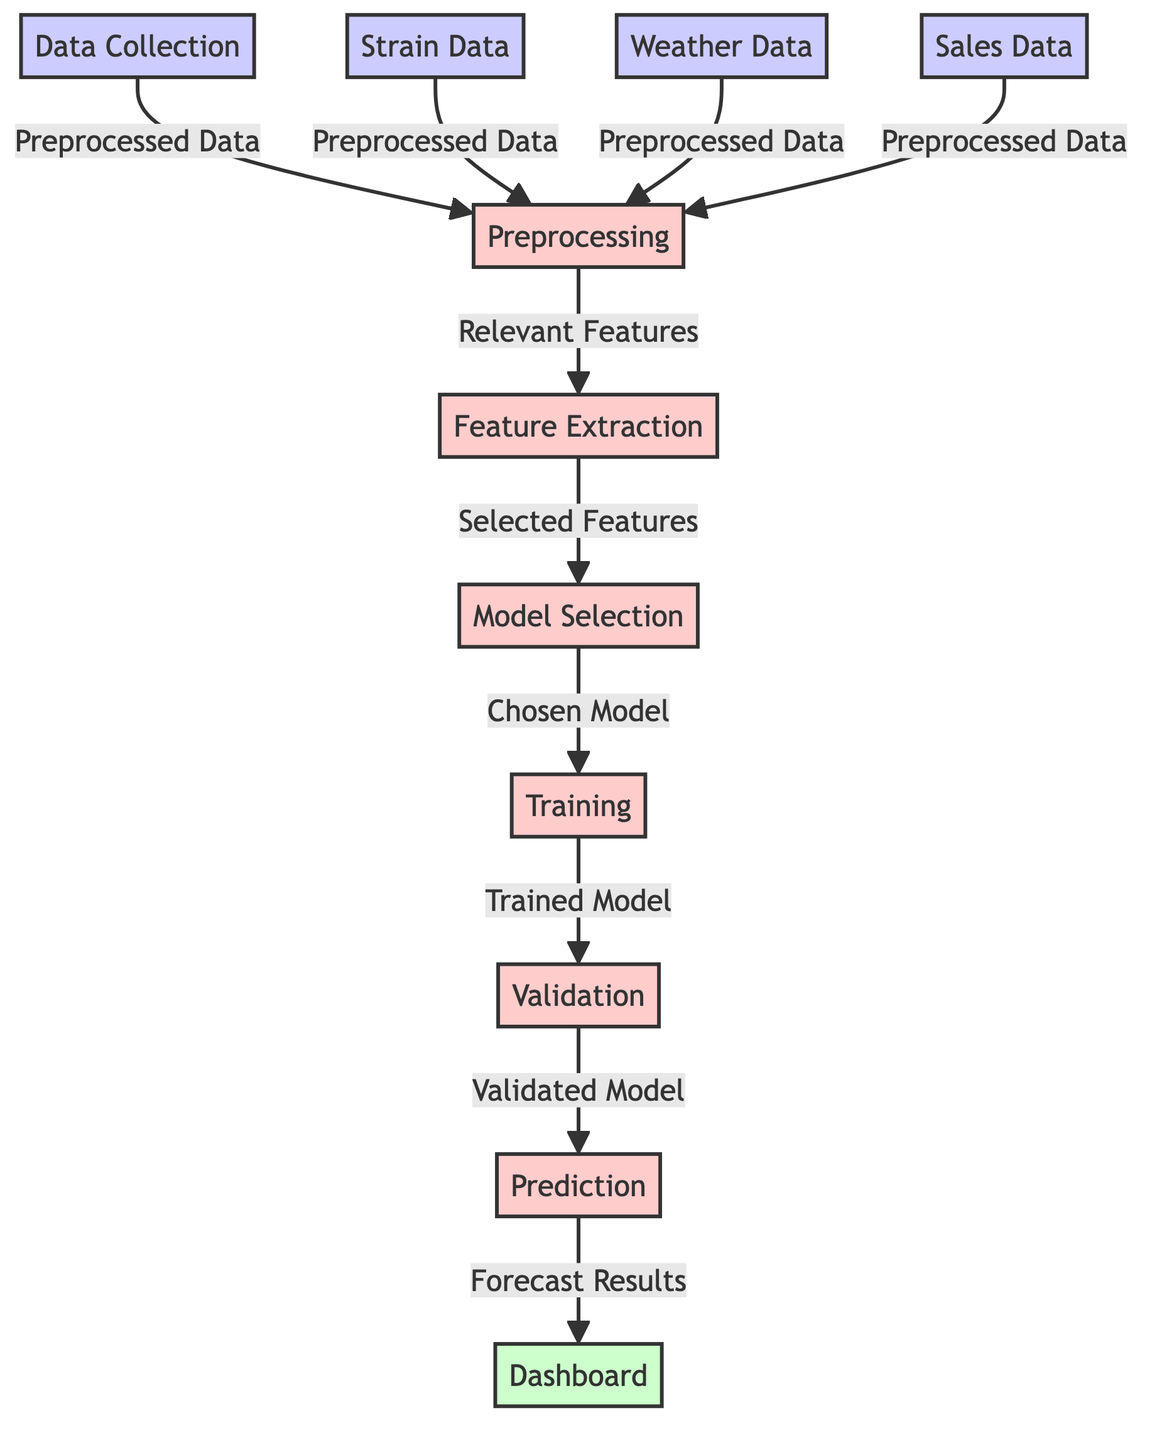What is the first step in the diagram? The first step in the diagram is "Data Collection," where initial data types are collected for further processing.
Answer: Data Collection How many types of data are collected before preprocessing? There are four types of data collected before preprocessing, which are strain data, weather data, sales data, and the general data collection.
Answer: Four Which process follows the "Feature Extraction"? The process that follows "Feature Extraction" is "Model Selection," where the selected features are used to choose an appropriate model for forecasting.
Answer: Model Selection What type of output does the diagram produce? The diagram produces a "Dashboard" as the final output, displaying the forecast results for sales trends.
Answer: Dashboard What is passed from "Training" to "Validation"? The output that is passed from "Training" to "Validation" is the "Trained Model," which is evaluated to ensure accuracy before making predictions.
Answer: Trained Model How does "Weather Data" influence the overall process? "Weather Data" influences the overall process by being part of the data collection step that provides context for sales, allowing models to account for environmental factors when forecasting.
Answer: Context Why is "Preprocessing" important in this diagram? "Preprocessing" is important as it prepares and cleans the data from all sources, ensuring that only relevant features are utilized in the subsequent steps of feature extraction and model selection.
Answer: Prepares Data What comes after "Prediction" in this process? After "Prediction," the results are visualized and summarized in the "Dashboard," offering insights into future revenue and sales trends for different cannabis strains.
Answer: Dashboard Which node indicates the final result of the machine learning pipeline? The final result of the machine learning pipeline is indicated by the "Dashboard," where the forecast results are presented.
Answer: Dashboard 